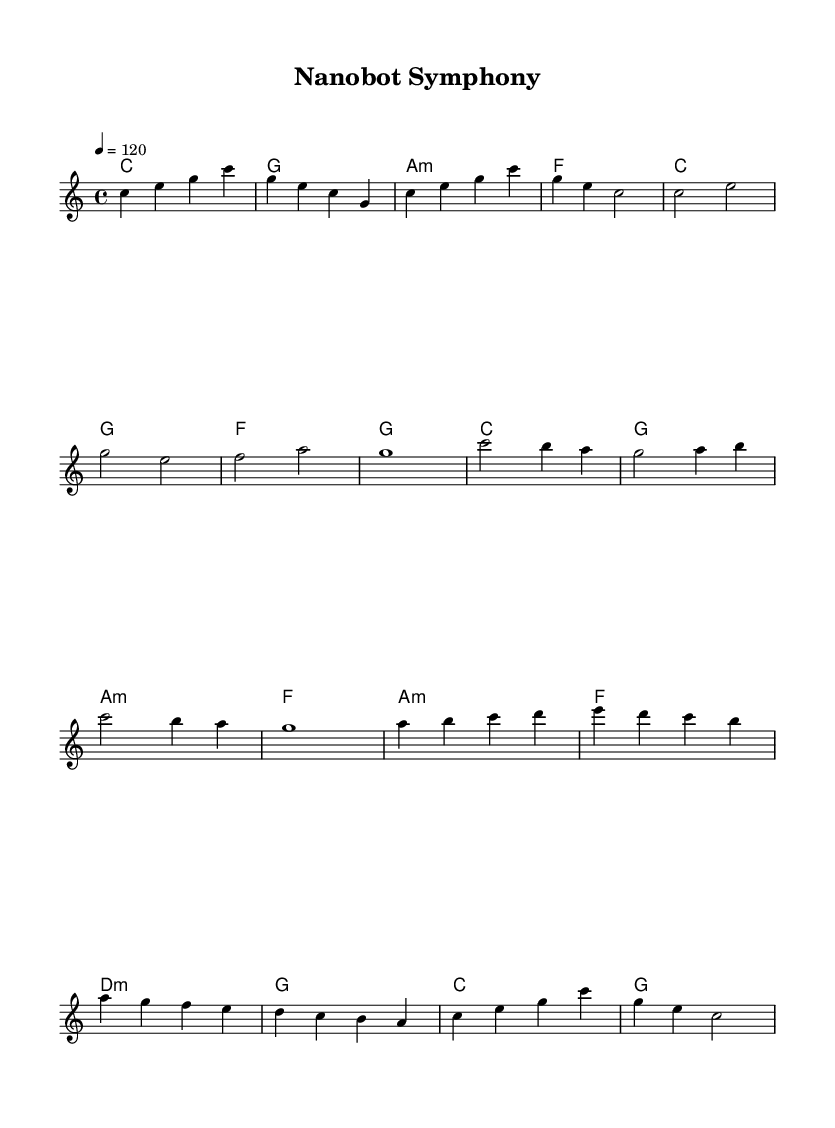What is the key signature of this music? The key signature is C major, which has no sharps or flats indicated on the staff. This can be confirmed by looking at the beginning of the score where the key signature is placed.
Answer: C major What is the time signature of this music? The time signature is 4/4, indicated at the beginning of the score. This means there are four beats in each measure and the quarter note gets one beat.
Answer: 4/4 What is the tempo marking for this music? The tempo marking is 120, noted as "4 = 120," meaning there are 120 beats per minute. This indicates the pace at which the music should be played.
Answer: 120 How many measures are in the melody? The melody consists of 16 measures, as counted from the beginning to the end of the melody section. Each line of music typically contains 4 measures.
Answer: 16 What is the overall theme represented by the title "Nanobot Symphony"? The title suggests an exploration of advanced technology, specifically nanobots, and how they may be represented in a symphonic, electronic style. This can be deduced from the combination of "Nanobot" (cutting-edge technology) and "Symphony" (musical form).
Answer: Technology Which section has the highest pitch notes in the melody? The bridge section contains the highest pitch notes, reaching up to the note 'd' which is higher than other sections. This can be identified by the placement of the notes in the staff.
Answer: Bridge section 